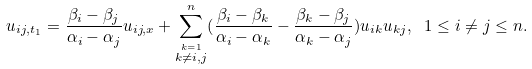Convert formula to latex. <formula><loc_0><loc_0><loc_500><loc_500>u _ { i j , t _ { 1 } } = \frac { \beta _ { i } - \beta _ { j } } { \alpha _ { i } - \alpha _ { j } } u _ { i j , x } + \sum ^ { n } _ { \stackrel { k = 1 } { k \not = i , j } } ( \frac { \beta _ { i } - \beta _ { k } } { \alpha _ { i } - \alpha _ { k } } - \frac { \beta _ { k } - \beta _ { j } } { \alpha _ { k } - \alpha _ { j } } ) u _ { i k } u _ { k j } , \ 1 \leq i \ne j \leq n .</formula> 